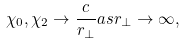<formula> <loc_0><loc_0><loc_500><loc_500>\chi _ { 0 } , \chi _ { 2 } \rightarrow \frac { c } { r _ { \perp } } a s r _ { \perp } \rightarrow \infty ,</formula> 